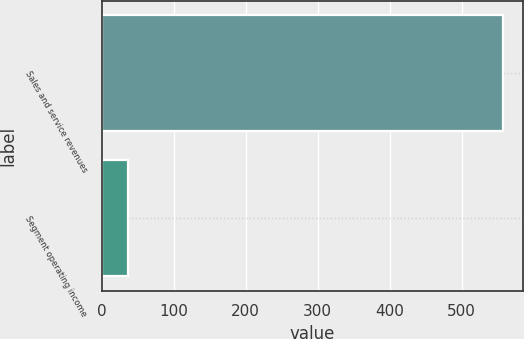<chart> <loc_0><loc_0><loc_500><loc_500><bar_chart><fcel>Sales and service revenues<fcel>Segment operating income<nl><fcel>558<fcel>36<nl></chart> 